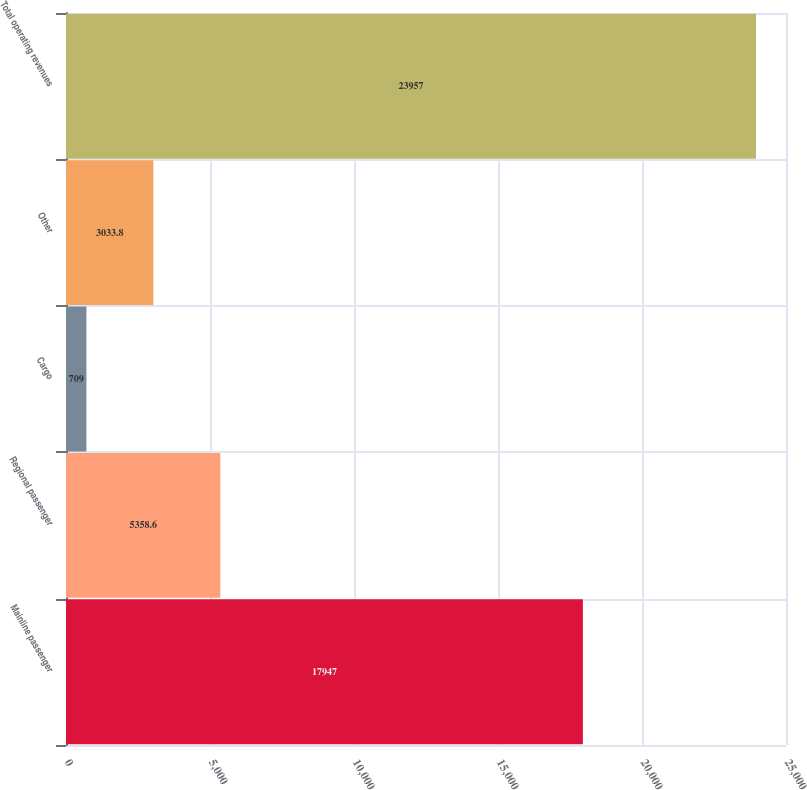Convert chart. <chart><loc_0><loc_0><loc_500><loc_500><bar_chart><fcel>Mainline passenger<fcel>Regional passenger<fcel>Cargo<fcel>Other<fcel>Total operating revenues<nl><fcel>17947<fcel>5358.6<fcel>709<fcel>3033.8<fcel>23957<nl></chart> 